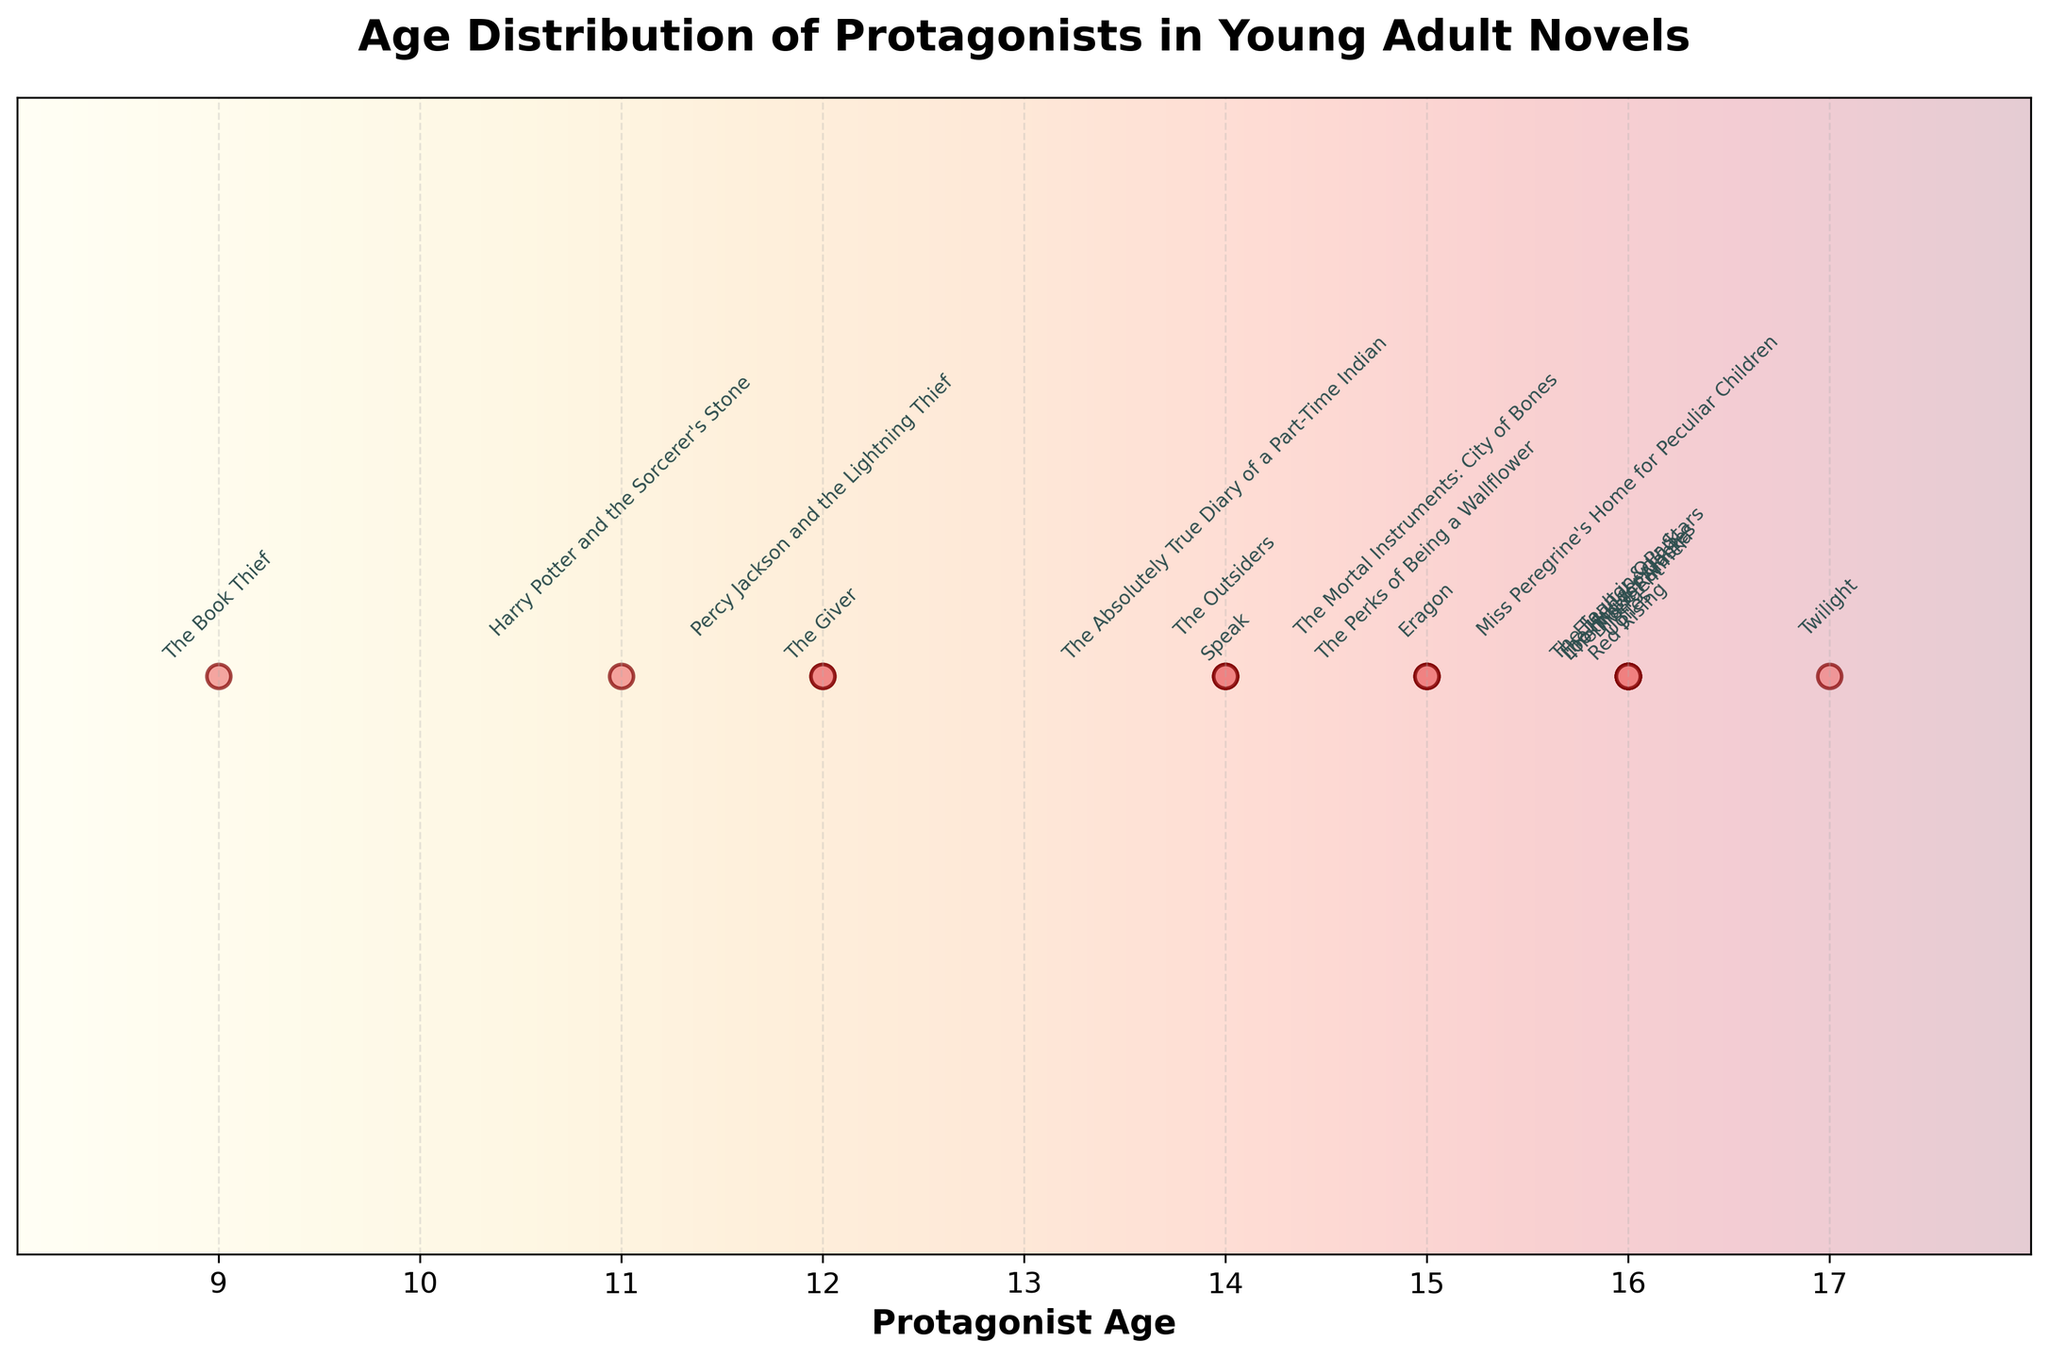What's the title of the plot? The title is usually prominently displayed at the top of the plot. In this case, it reads "Age Distribution of Protagonists in Young Adult Novels."
Answer: Age Distribution of Protagonists in Young Adult Novels What age appears most frequently in the plot? By looking at the distribution of points along the x-axis and annotating the book titles, the age 16 appears most frequently with multiple titles such as "The Hunger Games," "Divergent," and "Looking for Alaska."
Answer: 16 Which book has the youngest protagonist? The plot annotations show the book titles at different ages. The lowest age on the x-axis is 9, where "The Book Thief" is annotated.
Answer: The Book Thief How many books feature protagonists aged 12 years? Observing the count of points around the age 12 on the x-axis, we see "The Giver" and "Percy Jackson and the Lightning Thief." This means there are two books with protagonists aged 12.
Answer: 2 Which books have protagonists aged 14 years? Checking the annotations at age 14 along the x-axis, we find "The Absolutely True Diary of a Part-Time Indian," "The Outsiders," and "Speak."
Answer: "The Absolutely True Diary of a Part-Time Indian," "The Outsiders," and "Speak" What's the median protagonist age in the dataset? Arrange ages in ascending order: 9, 11, 12, 12, 14, 14, 14, 15, 15, 15, 16, 16, 16, 16, 16, 16, 16, 16, 17; the middle value (10th) is 16.
Answer: 16 Is there an even distribution of protagonist ages between 9 and 17? By observing the scatter points on the x-axis, ages between 9 and 17 are not evenly distributed, with concentrations at specific ages like 12, 14, 15, and notably 16.
Answer: No Which book is annotated near the upper end of the plot at age 17? The annotation of "Twilight" appears near the age 17 mark on the x-axis.
Answer: Twilight What is the range of protagonist ages in the dataset? The minimum age is 9 ("The Book Thief") and the maximum age is 17 ("Twilight"). Thus, the range is 17 - 9 = 8 years.
Answer: 8 years What is the total number of books represented in the plot? Counting all the data points along the x-axis reveals a total of 20 books, each annotated with a book title.
Answer: 20 